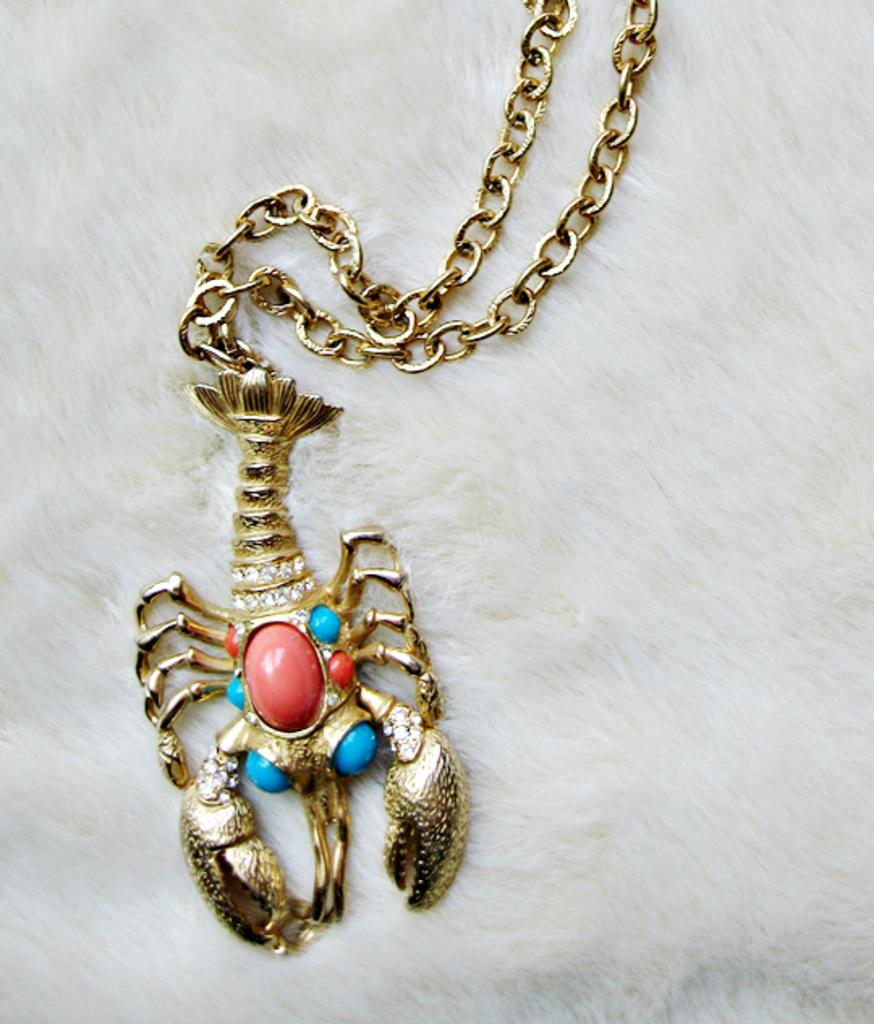What is the main object in the image? There is a chain in the image. What is the chain attached to? The chain is attached to a scorpion locket. How much does the carpenter charge for the waves in the image? There are no waves or carpenters present in the image. 